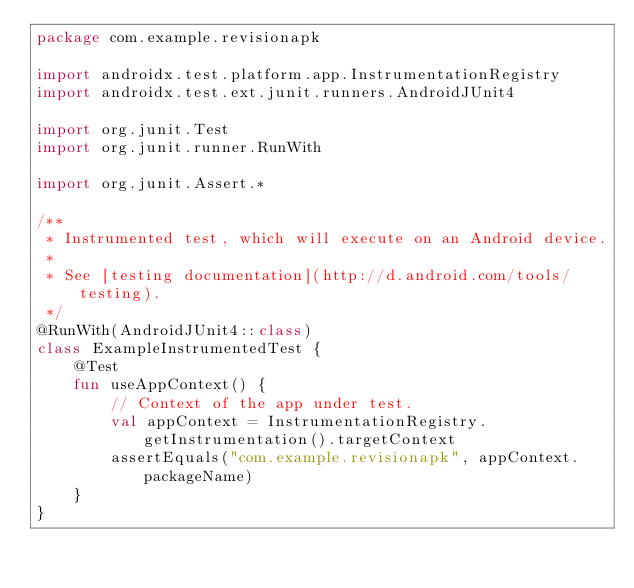<code> <loc_0><loc_0><loc_500><loc_500><_Kotlin_>package com.example.revisionapk

import androidx.test.platform.app.InstrumentationRegistry
import androidx.test.ext.junit.runners.AndroidJUnit4

import org.junit.Test
import org.junit.runner.RunWith

import org.junit.Assert.*

/**
 * Instrumented test, which will execute on an Android device.
 *
 * See [testing documentation](http://d.android.com/tools/testing).
 */
@RunWith(AndroidJUnit4::class)
class ExampleInstrumentedTest {
    @Test
    fun useAppContext() {
        // Context of the app under test.
        val appContext = InstrumentationRegistry.getInstrumentation().targetContext
        assertEquals("com.example.revisionapk", appContext.packageName)
    }
}</code> 